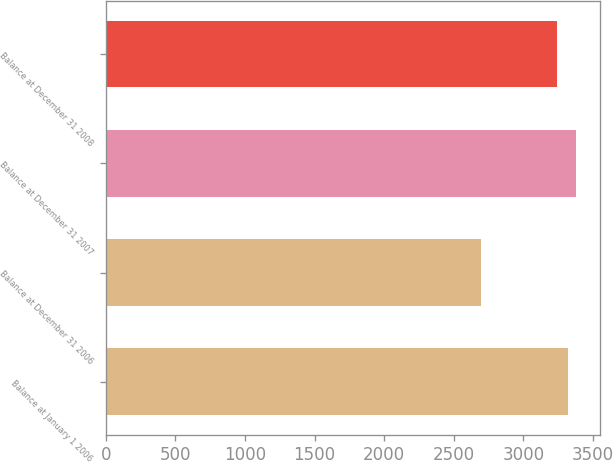Convert chart. <chart><loc_0><loc_0><loc_500><loc_500><bar_chart><fcel>Balance at January 1 2006<fcel>Balance at December 31 2006<fcel>Balance at December 31 2007<fcel>Balance at December 31 2008<nl><fcel>3319<fcel>2697<fcel>3382<fcel>3245<nl></chart> 